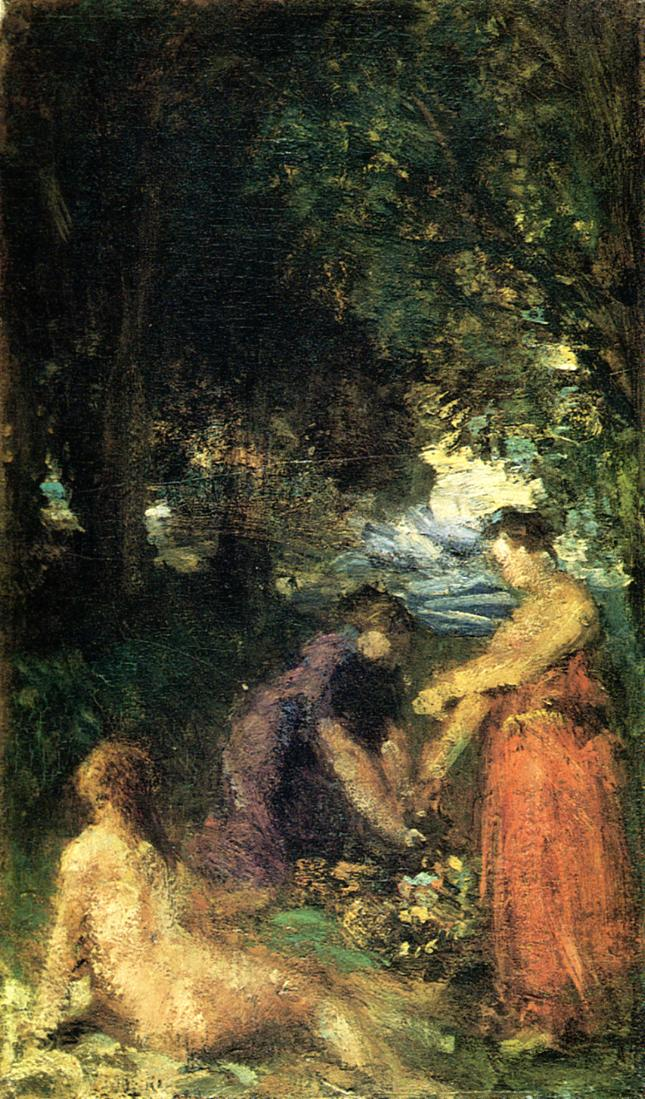Realistically speaking, what could be the significance of this gathering in the painting? Realistically, this gathering might represent a simple yet heartfelt moment where friends or family have come together to enjoy each other’s company and the serenity of nature. Such gatherings could be a reprieve from daily life, offering an opportunity for relaxation, reflection, and reconnection. The scene could signify the significance of relationships and the human need for communion with nature and loved ones. 